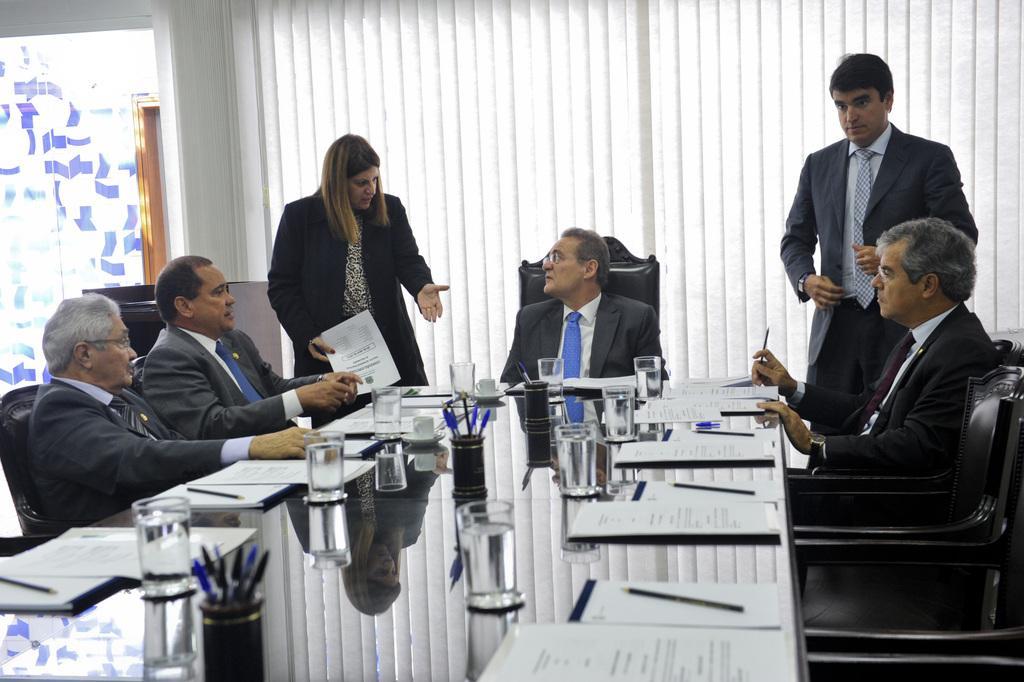Could you give a brief overview of what you see in this image? Few persons sitting on the chair. These two persons standing. This person holding paper. We can see table on the table we can see glasses,pens,books,papers. On the background we can see glass window,wall. 